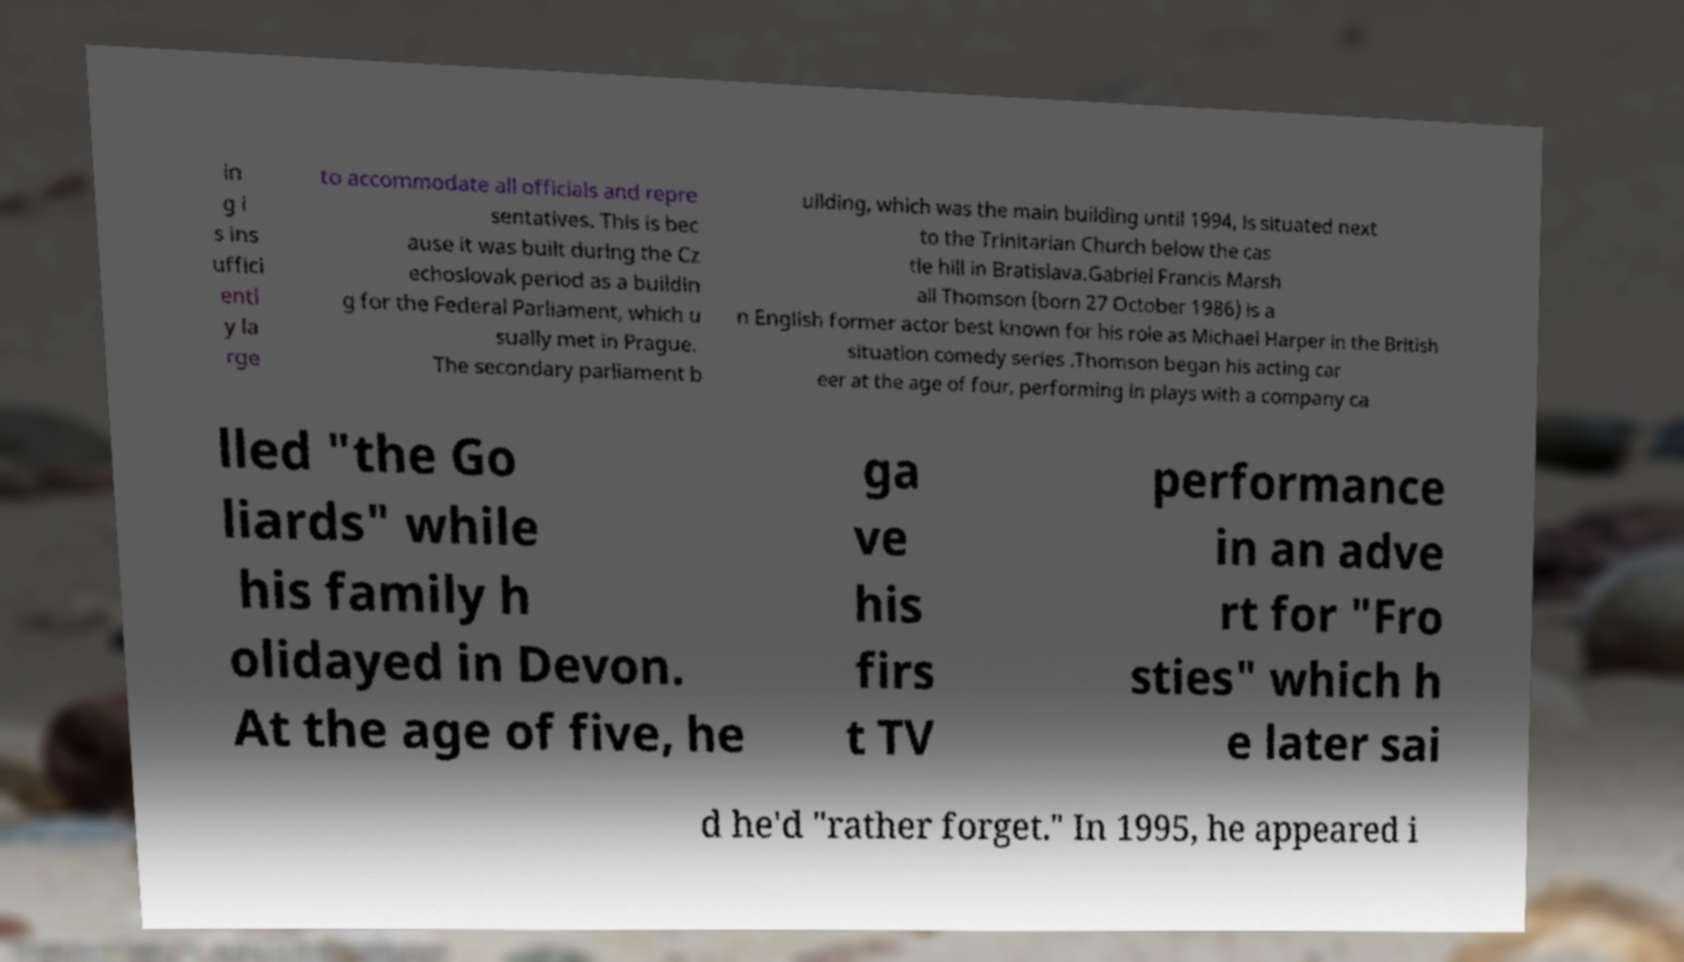What messages or text are displayed in this image? I need them in a readable, typed format. in g i s ins uffici entl y la rge to accommodate all officials and repre sentatives. This is bec ause it was built during the Cz echoslovak period as a buildin g for the Federal Parliament, which u sually met in Prague. The secondary parliament b uilding, which was the main building until 1994, is situated next to the Trinitarian Church below the cas tle hill in Bratislava.Gabriel Francis Marsh all Thomson (born 27 October 1986) is a n English former actor best known for his role as Michael Harper in the British situation comedy series .Thomson began his acting car eer at the age of four, performing in plays with a company ca lled "the Go liards" while his family h olidayed in Devon. At the age of five, he ga ve his firs t TV performance in an adve rt for "Fro sties" which h e later sai d he'd "rather forget." In 1995, he appeared i 